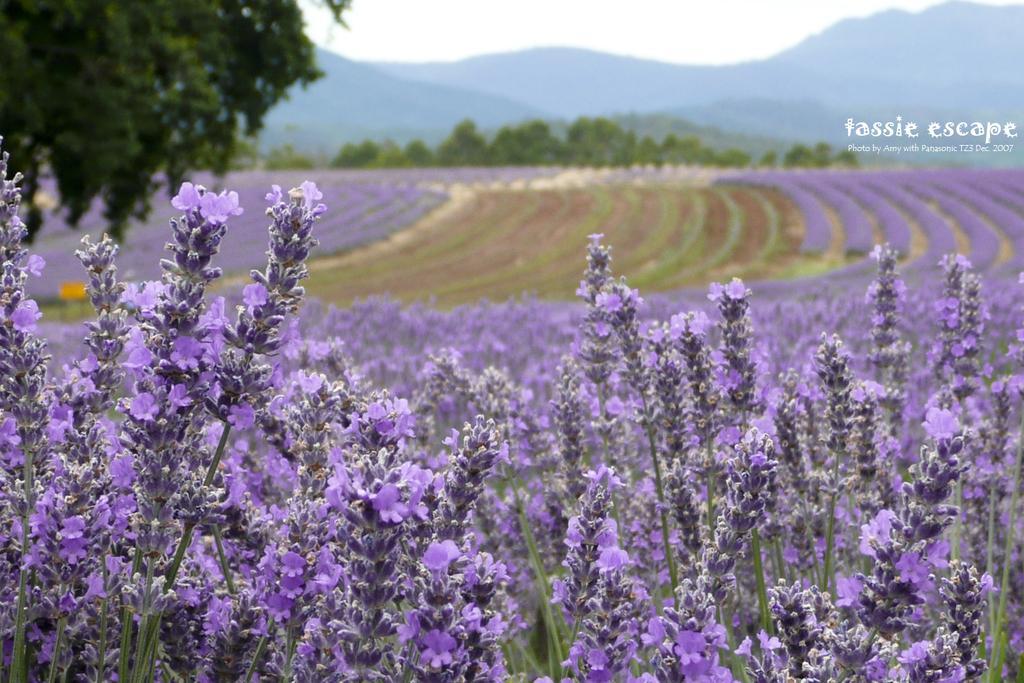Describe this image in one or two sentences. In the image we can see tiny flowers, purple in color. We can even see there are trees, mountains and the sky. On the top right, we can see the watermark. 